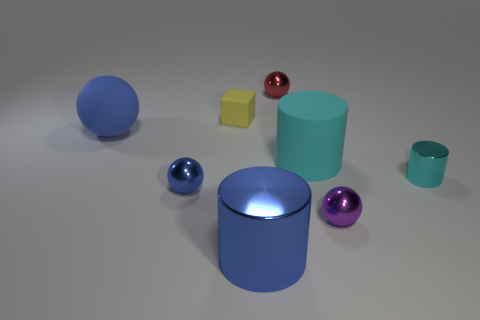There is a large object that is the same color as the big ball; what is its shape?
Ensure brevity in your answer.  Cylinder. What number of big objects are on the right side of the small blue sphere and to the left of the cyan matte object?
Keep it short and to the point. 1. How many things are either large blue things or cylinders on the right side of the small purple metal thing?
Offer a very short reply. 3. Are there more tiny balls than big blue matte spheres?
Your response must be concise. Yes. What shape is the big matte object that is left of the large blue cylinder?
Offer a very short reply. Sphere. How many other red metallic things are the same shape as the red metal object?
Provide a succinct answer. 0. How big is the blue object behind the small metallic thing to the left of the tiny yellow matte object?
Offer a terse response. Large. How many cyan things are cubes or rubber cylinders?
Ensure brevity in your answer.  1. Is the number of small blue objects that are on the right side of the small yellow rubber object less than the number of tiny rubber things that are in front of the purple metallic ball?
Provide a short and direct response. No. Is the size of the yellow matte block the same as the metallic cylinder in front of the small blue metallic object?
Your answer should be very brief. No. 